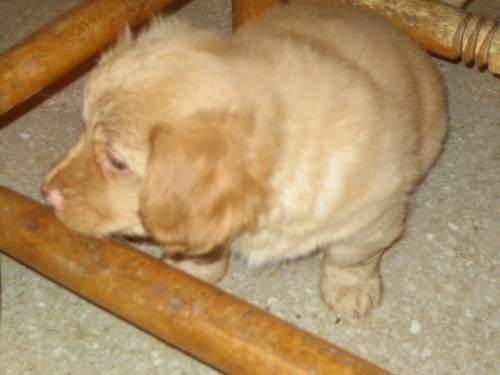How might the puppy be feeling in this environment, based on its posture and expression? The puppy's relaxed posture, with a somewhat downward gaze and lack of tension in the body, suggests that it is at ease in its current environment. It doesn't seem to be poised for action but rather settled comfortably, indicating a sense of security and contentment. 